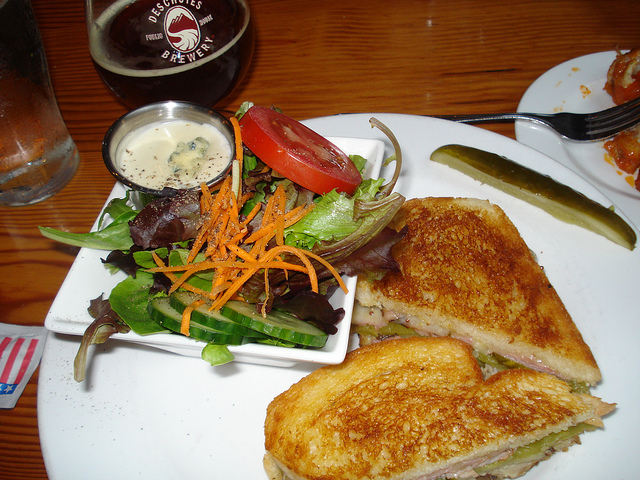Read all the text in this image. DESCROTES BREWERY 